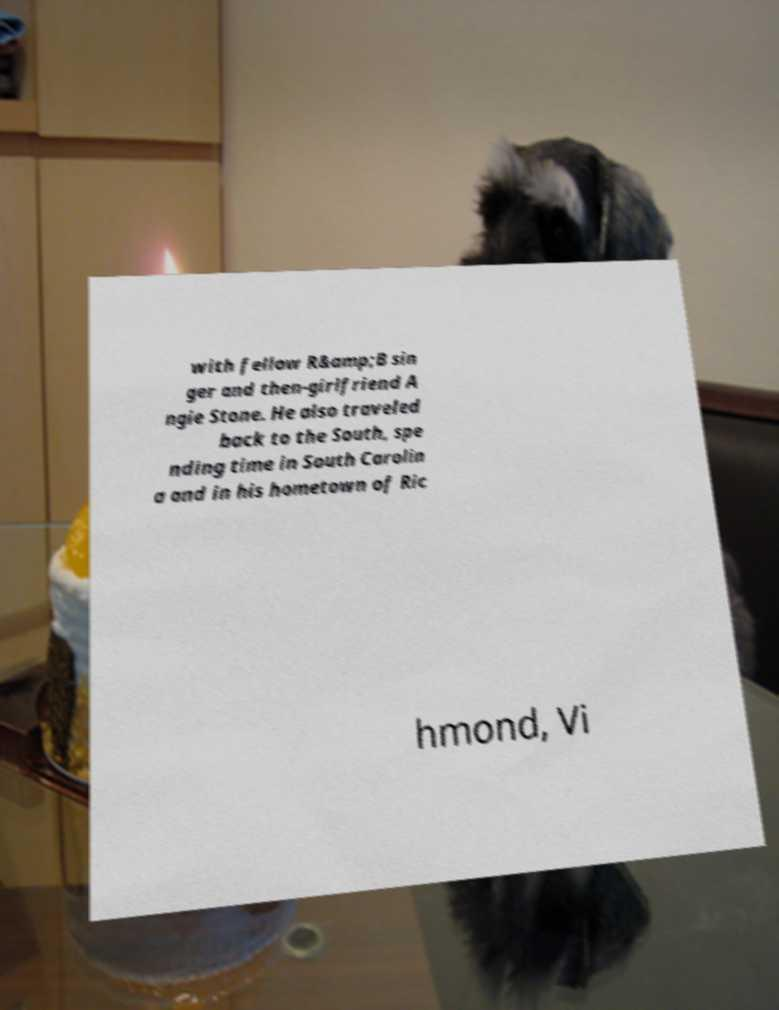Could you extract and type out the text from this image? with fellow R&amp;B sin ger and then-girlfriend A ngie Stone. He also traveled back to the South, spe nding time in South Carolin a and in his hometown of Ric hmond, Vi 